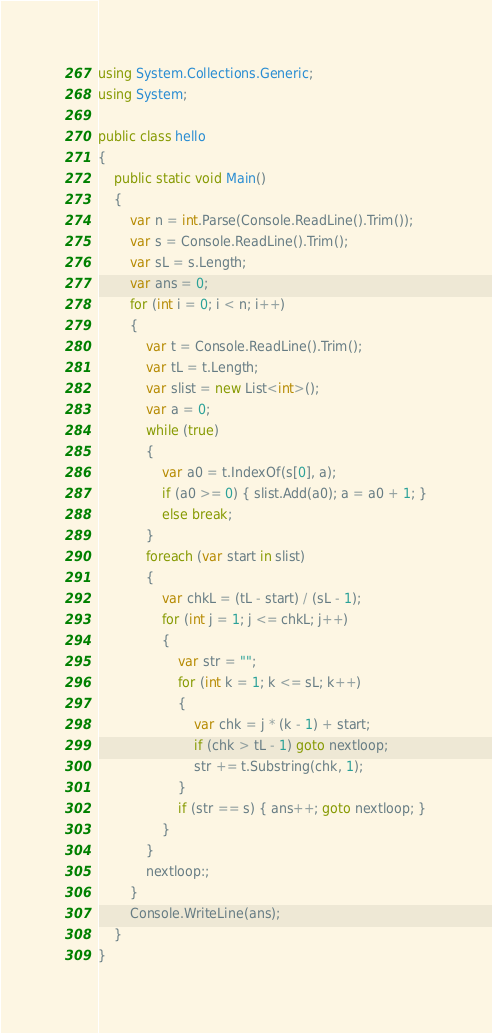<code> <loc_0><loc_0><loc_500><loc_500><_C#_>using System.Collections.Generic;
using System;

public class hello
{
    public static void Main()
    {
        var n = int.Parse(Console.ReadLine().Trim());
        var s = Console.ReadLine().Trim();
        var sL = s.Length;
        var ans = 0;
        for (int i = 0; i < n; i++)
        {
            var t = Console.ReadLine().Trim();
            var tL = t.Length;
            var slist = new List<int>();
            var a = 0;
            while (true)
            {
                var a0 = t.IndexOf(s[0], a);
                if (a0 >= 0) { slist.Add(a0); a = a0 + 1; }
                else break;
            }
            foreach (var start in slist)
            {
                var chkL = (tL - start) / (sL - 1);
                for (int j = 1; j <= chkL; j++)
                {
                    var str = "";
                    for (int k = 1; k <= sL; k++)
                    {
                        var chk = j * (k - 1) + start;
                        if (chk > tL - 1) goto nextloop;
                        str += t.Substring(chk, 1);
                    }
                    if (str == s) { ans++; goto nextloop; }
                }
            }
            nextloop:;
        }
        Console.WriteLine(ans);
    }
}</code> 